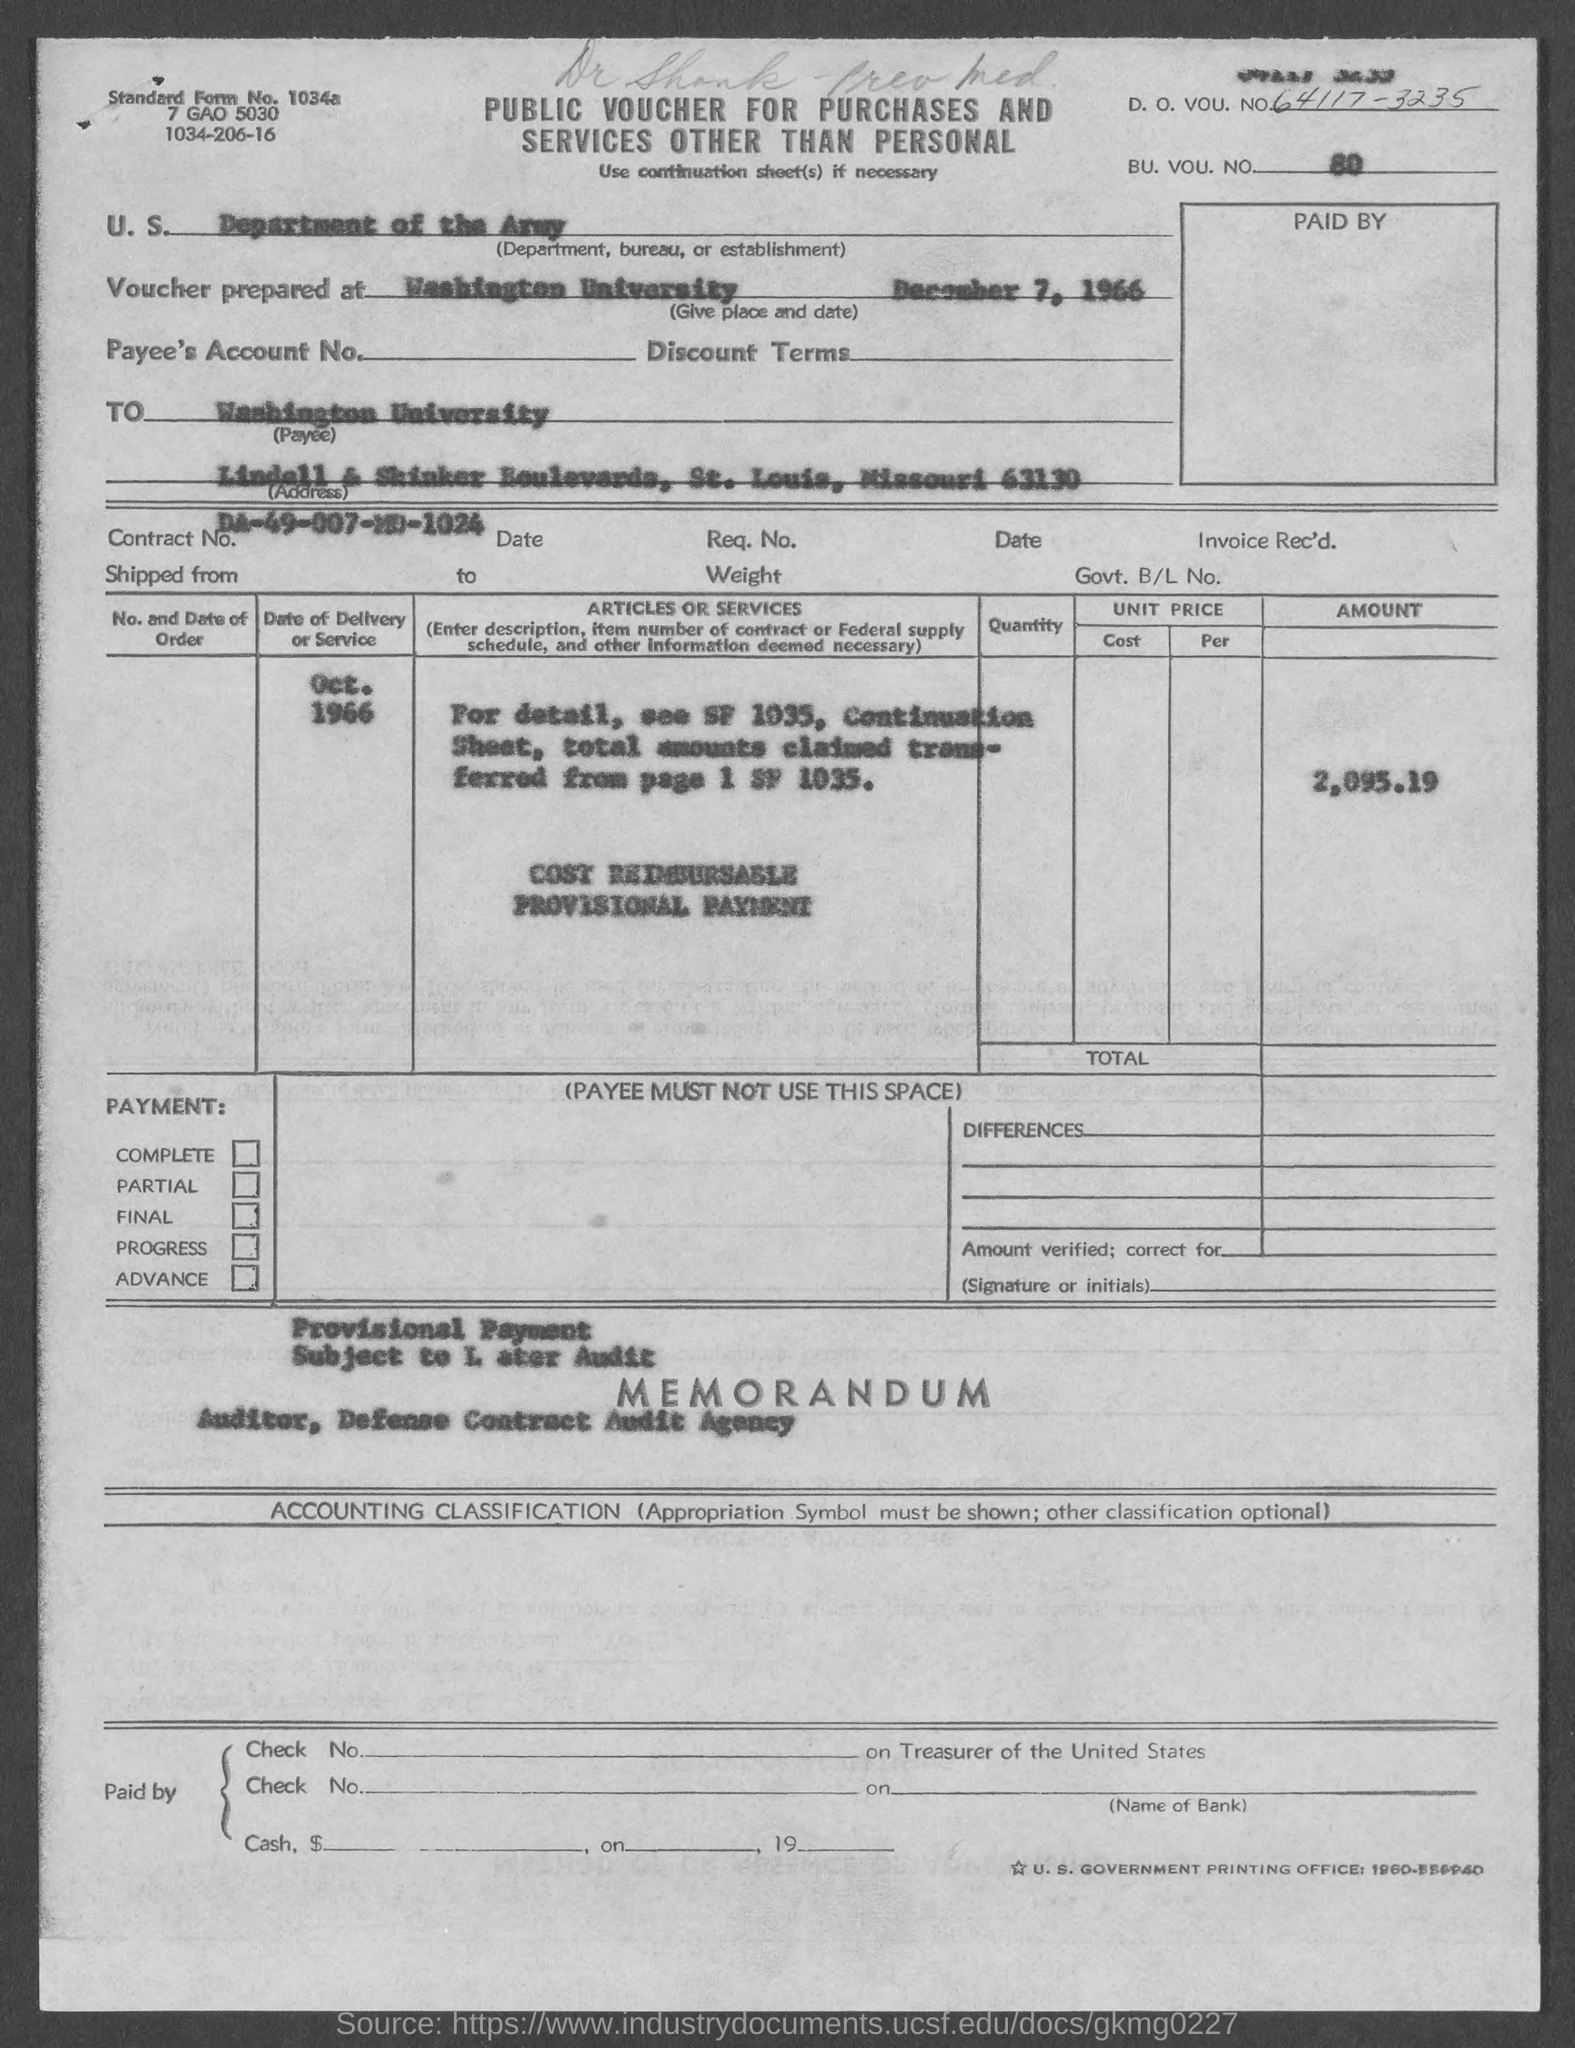Mention a couple of crucial points in this snapshot. A public voucher is given for purchases and services other than personal. The voucher indicates that the U.S. Department, Bureau, or Establishment is the Department of the Army. The voucher mentions a BU. VOU. NO. of 80. The voucher was prepared at Washington University on December 7, 1966. The voucher contains the Contract No. DA-49-007-MD-1024. 